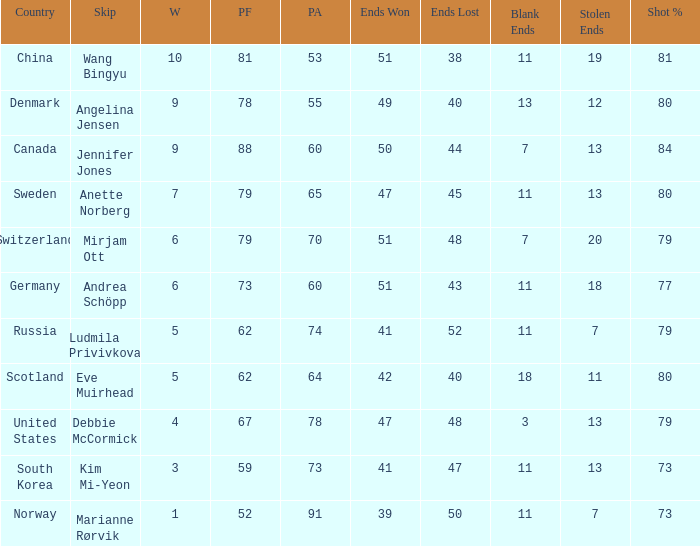When the country was Scotland, how many ends were won? 1.0. 